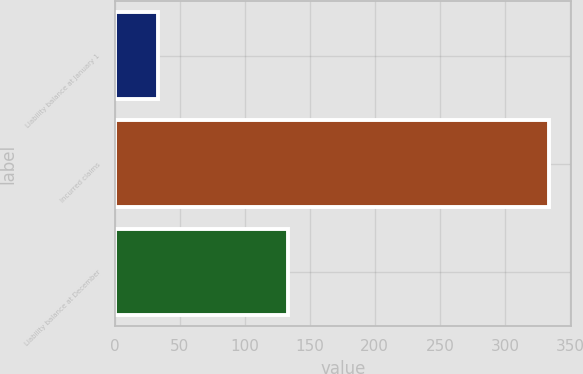Convert chart. <chart><loc_0><loc_0><loc_500><loc_500><bar_chart><fcel>Liability balance at January 1<fcel>Incurred claims<fcel>Liability balance at December<nl><fcel>33<fcel>334<fcel>133.4<nl></chart> 